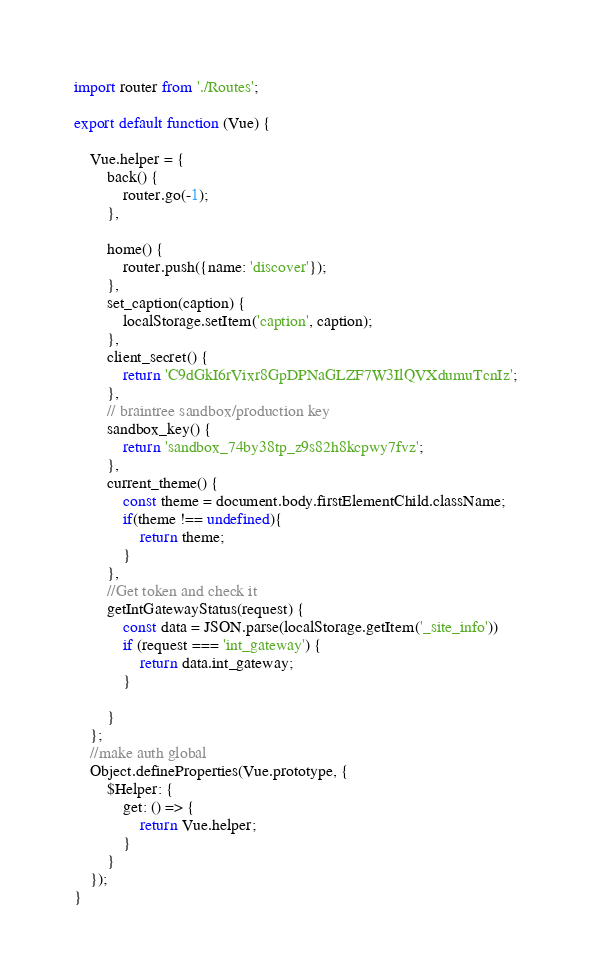<code> <loc_0><loc_0><loc_500><loc_500><_JavaScript_>import router from './Routes';

export default function (Vue) {

    Vue.helper = {
        back() {
            router.go(-1);
        },

        home() {
            router.push({name: 'discover'});
        },
        set_caption(caption) {
            localStorage.setItem('caption', caption);
        },
        client_secret() {
            return 'C9dGkI6rVixr8GpDPNaGLZF7W3IlQVXdumuTcnIz';
        },
        // braintree sandbox/production key
        sandbox_key() {
            return 'sandbox_74by38tp_z9s82h8kcpwy7fvz';
        },
        current_theme() {
            const theme = document.body.firstElementChild.className;
            if(theme !== undefined){
                return theme;
            }
        },
        //Get token and check it
        getIntGatewayStatus(request) {
            const data = JSON.parse(localStorage.getItem('_site_info'))
            if (request === 'int_gateway') {
                return data.int_gateway;
            }

        }
    };
    //make auth global
    Object.defineProperties(Vue.prototype, {
        $Helper: {
            get: () => {
                return Vue.helper;
            }
        }
    });
}
</code> 